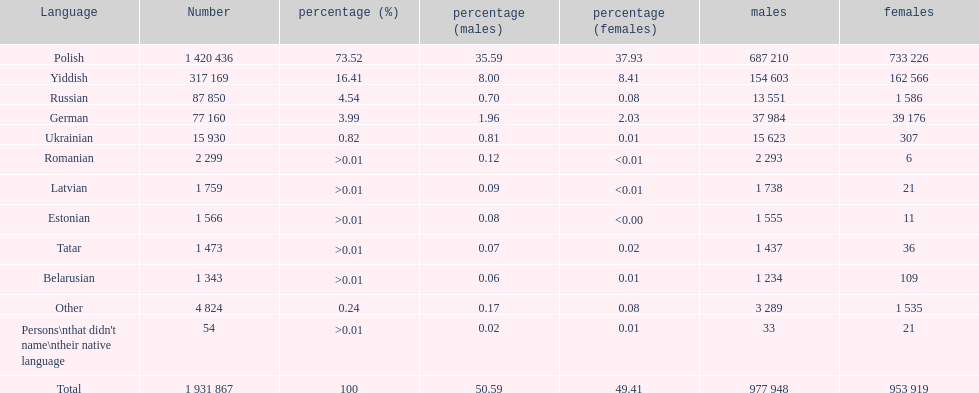What was the next most commonly spoken language in poland after russian? German. 